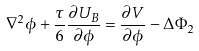Convert formula to latex. <formula><loc_0><loc_0><loc_500><loc_500>\nabla ^ { 2 } \phi + \frac { \tau } { 6 } \frac { \partial U _ { B } } { \partial \phi } = \frac { \partial V } { \partial \phi } - \Delta \Phi _ { 2 }</formula> 